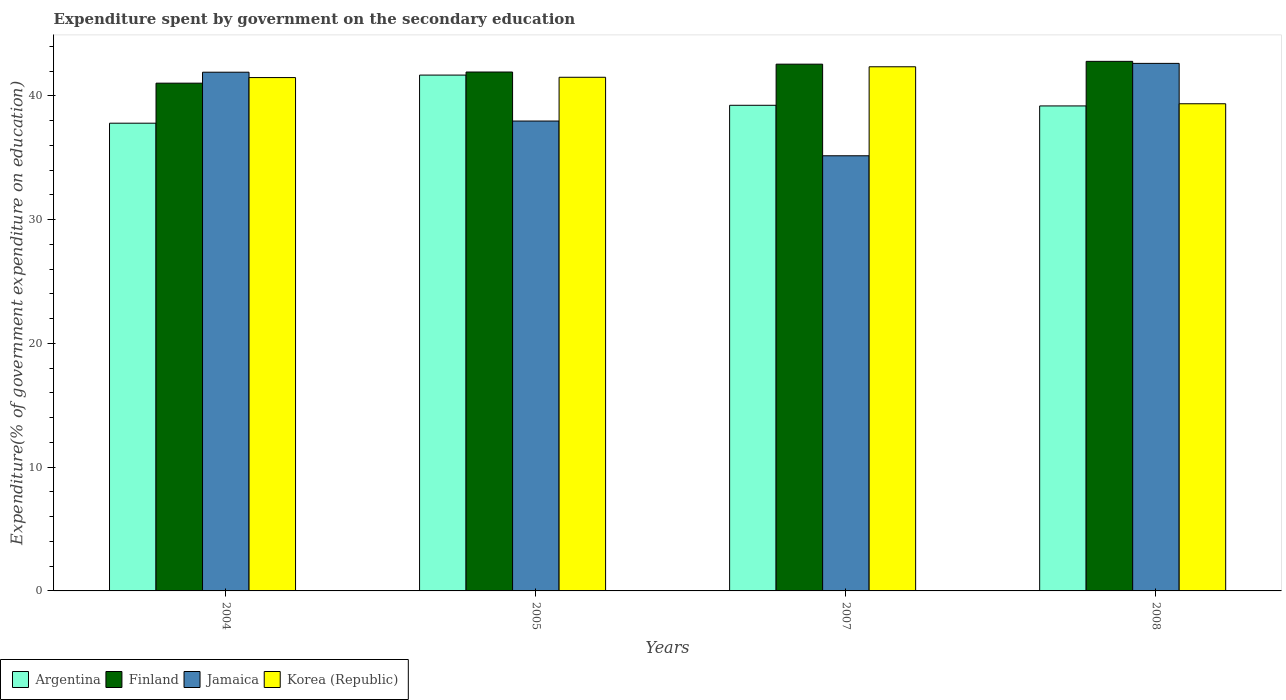How many different coloured bars are there?
Offer a terse response. 4. Are the number of bars per tick equal to the number of legend labels?
Offer a very short reply. Yes. In how many cases, is the number of bars for a given year not equal to the number of legend labels?
Provide a short and direct response. 0. What is the expenditure spent by government on the secondary education in Finland in 2007?
Provide a short and direct response. 42.57. Across all years, what is the maximum expenditure spent by government on the secondary education in Jamaica?
Your answer should be very brief. 42.63. Across all years, what is the minimum expenditure spent by government on the secondary education in Korea (Republic)?
Provide a short and direct response. 39.37. In which year was the expenditure spent by government on the secondary education in Argentina maximum?
Ensure brevity in your answer.  2005. In which year was the expenditure spent by government on the secondary education in Finland minimum?
Your response must be concise. 2004. What is the total expenditure spent by government on the secondary education in Korea (Republic) in the graph?
Provide a short and direct response. 164.72. What is the difference between the expenditure spent by government on the secondary education in Jamaica in 2004 and that in 2008?
Offer a very short reply. -0.71. What is the difference between the expenditure spent by government on the secondary education in Jamaica in 2008 and the expenditure spent by government on the secondary education in Korea (Republic) in 2005?
Offer a terse response. 1.12. What is the average expenditure spent by government on the secondary education in Jamaica per year?
Provide a short and direct response. 39.42. In the year 2005, what is the difference between the expenditure spent by government on the secondary education in Finland and expenditure spent by government on the secondary education in Jamaica?
Make the answer very short. 3.96. What is the ratio of the expenditure spent by government on the secondary education in Korea (Republic) in 2005 to that in 2007?
Your answer should be very brief. 0.98. Is the expenditure spent by government on the secondary education in Korea (Republic) in 2004 less than that in 2007?
Give a very brief answer. Yes. What is the difference between the highest and the second highest expenditure spent by government on the secondary education in Finland?
Offer a terse response. 0.23. What is the difference between the highest and the lowest expenditure spent by government on the secondary education in Jamaica?
Your answer should be very brief. 7.47. Is the sum of the expenditure spent by government on the secondary education in Korea (Republic) in 2004 and 2005 greater than the maximum expenditure spent by government on the secondary education in Argentina across all years?
Offer a terse response. Yes. Is it the case that in every year, the sum of the expenditure spent by government on the secondary education in Jamaica and expenditure spent by government on the secondary education in Finland is greater than the sum of expenditure spent by government on the secondary education in Korea (Republic) and expenditure spent by government on the secondary education in Argentina?
Ensure brevity in your answer.  Yes. What does the 3rd bar from the right in 2007 represents?
Keep it short and to the point. Finland. How many bars are there?
Offer a terse response. 16. Are all the bars in the graph horizontal?
Give a very brief answer. No. How many years are there in the graph?
Your response must be concise. 4. Where does the legend appear in the graph?
Offer a terse response. Bottom left. How many legend labels are there?
Make the answer very short. 4. How are the legend labels stacked?
Ensure brevity in your answer.  Horizontal. What is the title of the graph?
Keep it short and to the point. Expenditure spent by government on the secondary education. Does "Dominican Republic" appear as one of the legend labels in the graph?
Your answer should be compact. No. What is the label or title of the X-axis?
Your response must be concise. Years. What is the label or title of the Y-axis?
Offer a terse response. Expenditure(% of government expenditure on education). What is the Expenditure(% of government expenditure on education) of Argentina in 2004?
Keep it short and to the point. 37.8. What is the Expenditure(% of government expenditure on education) of Finland in 2004?
Your response must be concise. 41.03. What is the Expenditure(% of government expenditure on education) in Jamaica in 2004?
Offer a terse response. 41.92. What is the Expenditure(% of government expenditure on education) of Korea (Republic) in 2004?
Give a very brief answer. 41.49. What is the Expenditure(% of government expenditure on education) of Argentina in 2005?
Your answer should be very brief. 41.69. What is the Expenditure(% of government expenditure on education) in Finland in 2005?
Provide a short and direct response. 41.93. What is the Expenditure(% of government expenditure on education) of Jamaica in 2005?
Give a very brief answer. 37.97. What is the Expenditure(% of government expenditure on education) in Korea (Republic) in 2005?
Provide a short and direct response. 41.51. What is the Expenditure(% of government expenditure on education) in Argentina in 2007?
Your answer should be very brief. 39.25. What is the Expenditure(% of government expenditure on education) in Finland in 2007?
Provide a succinct answer. 42.57. What is the Expenditure(% of government expenditure on education) of Jamaica in 2007?
Provide a succinct answer. 35.17. What is the Expenditure(% of government expenditure on education) in Korea (Republic) in 2007?
Provide a short and direct response. 42.36. What is the Expenditure(% of government expenditure on education) of Argentina in 2008?
Provide a short and direct response. 39.19. What is the Expenditure(% of government expenditure on education) in Finland in 2008?
Give a very brief answer. 42.8. What is the Expenditure(% of government expenditure on education) of Jamaica in 2008?
Your answer should be compact. 42.63. What is the Expenditure(% of government expenditure on education) in Korea (Republic) in 2008?
Give a very brief answer. 39.37. Across all years, what is the maximum Expenditure(% of government expenditure on education) of Argentina?
Make the answer very short. 41.69. Across all years, what is the maximum Expenditure(% of government expenditure on education) in Finland?
Keep it short and to the point. 42.8. Across all years, what is the maximum Expenditure(% of government expenditure on education) of Jamaica?
Make the answer very short. 42.63. Across all years, what is the maximum Expenditure(% of government expenditure on education) in Korea (Republic)?
Your response must be concise. 42.36. Across all years, what is the minimum Expenditure(% of government expenditure on education) in Argentina?
Your answer should be very brief. 37.8. Across all years, what is the minimum Expenditure(% of government expenditure on education) of Finland?
Offer a very short reply. 41.03. Across all years, what is the minimum Expenditure(% of government expenditure on education) in Jamaica?
Your answer should be very brief. 35.17. Across all years, what is the minimum Expenditure(% of government expenditure on education) in Korea (Republic)?
Your response must be concise. 39.37. What is the total Expenditure(% of government expenditure on education) in Argentina in the graph?
Ensure brevity in your answer.  157.93. What is the total Expenditure(% of government expenditure on education) in Finland in the graph?
Ensure brevity in your answer.  168.33. What is the total Expenditure(% of government expenditure on education) in Jamaica in the graph?
Your answer should be very brief. 157.69. What is the total Expenditure(% of government expenditure on education) in Korea (Republic) in the graph?
Provide a short and direct response. 164.72. What is the difference between the Expenditure(% of government expenditure on education) of Argentina in 2004 and that in 2005?
Give a very brief answer. -3.89. What is the difference between the Expenditure(% of government expenditure on education) in Finland in 2004 and that in 2005?
Your response must be concise. -0.9. What is the difference between the Expenditure(% of government expenditure on education) in Jamaica in 2004 and that in 2005?
Your response must be concise. 3.95. What is the difference between the Expenditure(% of government expenditure on education) in Korea (Republic) in 2004 and that in 2005?
Your answer should be very brief. -0.02. What is the difference between the Expenditure(% of government expenditure on education) of Argentina in 2004 and that in 2007?
Offer a very short reply. -1.45. What is the difference between the Expenditure(% of government expenditure on education) in Finland in 2004 and that in 2007?
Give a very brief answer. -1.54. What is the difference between the Expenditure(% of government expenditure on education) of Jamaica in 2004 and that in 2007?
Offer a terse response. 6.75. What is the difference between the Expenditure(% of government expenditure on education) in Korea (Republic) in 2004 and that in 2007?
Provide a short and direct response. -0.87. What is the difference between the Expenditure(% of government expenditure on education) in Argentina in 2004 and that in 2008?
Give a very brief answer. -1.39. What is the difference between the Expenditure(% of government expenditure on education) in Finland in 2004 and that in 2008?
Ensure brevity in your answer.  -1.76. What is the difference between the Expenditure(% of government expenditure on education) of Jamaica in 2004 and that in 2008?
Provide a succinct answer. -0.71. What is the difference between the Expenditure(% of government expenditure on education) of Korea (Republic) in 2004 and that in 2008?
Give a very brief answer. 2.12. What is the difference between the Expenditure(% of government expenditure on education) in Argentina in 2005 and that in 2007?
Provide a short and direct response. 2.44. What is the difference between the Expenditure(% of government expenditure on education) of Finland in 2005 and that in 2007?
Provide a short and direct response. -0.63. What is the difference between the Expenditure(% of government expenditure on education) of Jamaica in 2005 and that in 2007?
Offer a very short reply. 2.81. What is the difference between the Expenditure(% of government expenditure on education) of Korea (Republic) in 2005 and that in 2007?
Provide a succinct answer. -0.85. What is the difference between the Expenditure(% of government expenditure on education) in Argentina in 2005 and that in 2008?
Provide a short and direct response. 2.49. What is the difference between the Expenditure(% of government expenditure on education) of Finland in 2005 and that in 2008?
Your answer should be very brief. -0.86. What is the difference between the Expenditure(% of government expenditure on education) of Jamaica in 2005 and that in 2008?
Offer a very short reply. -4.66. What is the difference between the Expenditure(% of government expenditure on education) of Korea (Republic) in 2005 and that in 2008?
Provide a short and direct response. 2.14. What is the difference between the Expenditure(% of government expenditure on education) of Argentina in 2007 and that in 2008?
Give a very brief answer. 0.05. What is the difference between the Expenditure(% of government expenditure on education) of Finland in 2007 and that in 2008?
Provide a short and direct response. -0.23. What is the difference between the Expenditure(% of government expenditure on education) of Jamaica in 2007 and that in 2008?
Make the answer very short. -7.47. What is the difference between the Expenditure(% of government expenditure on education) in Korea (Republic) in 2007 and that in 2008?
Your answer should be very brief. 2.99. What is the difference between the Expenditure(% of government expenditure on education) in Argentina in 2004 and the Expenditure(% of government expenditure on education) in Finland in 2005?
Your answer should be very brief. -4.14. What is the difference between the Expenditure(% of government expenditure on education) in Argentina in 2004 and the Expenditure(% of government expenditure on education) in Jamaica in 2005?
Offer a terse response. -0.17. What is the difference between the Expenditure(% of government expenditure on education) of Argentina in 2004 and the Expenditure(% of government expenditure on education) of Korea (Republic) in 2005?
Offer a very short reply. -3.71. What is the difference between the Expenditure(% of government expenditure on education) in Finland in 2004 and the Expenditure(% of government expenditure on education) in Jamaica in 2005?
Offer a terse response. 3.06. What is the difference between the Expenditure(% of government expenditure on education) in Finland in 2004 and the Expenditure(% of government expenditure on education) in Korea (Republic) in 2005?
Provide a succinct answer. -0.48. What is the difference between the Expenditure(% of government expenditure on education) in Jamaica in 2004 and the Expenditure(% of government expenditure on education) in Korea (Republic) in 2005?
Make the answer very short. 0.41. What is the difference between the Expenditure(% of government expenditure on education) of Argentina in 2004 and the Expenditure(% of government expenditure on education) of Finland in 2007?
Offer a terse response. -4.77. What is the difference between the Expenditure(% of government expenditure on education) of Argentina in 2004 and the Expenditure(% of government expenditure on education) of Jamaica in 2007?
Your answer should be very brief. 2.63. What is the difference between the Expenditure(% of government expenditure on education) in Argentina in 2004 and the Expenditure(% of government expenditure on education) in Korea (Republic) in 2007?
Give a very brief answer. -4.56. What is the difference between the Expenditure(% of government expenditure on education) in Finland in 2004 and the Expenditure(% of government expenditure on education) in Jamaica in 2007?
Your response must be concise. 5.87. What is the difference between the Expenditure(% of government expenditure on education) in Finland in 2004 and the Expenditure(% of government expenditure on education) in Korea (Republic) in 2007?
Give a very brief answer. -1.32. What is the difference between the Expenditure(% of government expenditure on education) in Jamaica in 2004 and the Expenditure(% of government expenditure on education) in Korea (Republic) in 2007?
Offer a very short reply. -0.44. What is the difference between the Expenditure(% of government expenditure on education) of Argentina in 2004 and the Expenditure(% of government expenditure on education) of Finland in 2008?
Your answer should be very brief. -5. What is the difference between the Expenditure(% of government expenditure on education) of Argentina in 2004 and the Expenditure(% of government expenditure on education) of Jamaica in 2008?
Keep it short and to the point. -4.83. What is the difference between the Expenditure(% of government expenditure on education) of Argentina in 2004 and the Expenditure(% of government expenditure on education) of Korea (Republic) in 2008?
Your answer should be very brief. -1.57. What is the difference between the Expenditure(% of government expenditure on education) of Finland in 2004 and the Expenditure(% of government expenditure on education) of Jamaica in 2008?
Offer a terse response. -1.6. What is the difference between the Expenditure(% of government expenditure on education) of Finland in 2004 and the Expenditure(% of government expenditure on education) of Korea (Republic) in 2008?
Your answer should be very brief. 1.66. What is the difference between the Expenditure(% of government expenditure on education) in Jamaica in 2004 and the Expenditure(% of government expenditure on education) in Korea (Republic) in 2008?
Give a very brief answer. 2.55. What is the difference between the Expenditure(% of government expenditure on education) of Argentina in 2005 and the Expenditure(% of government expenditure on education) of Finland in 2007?
Make the answer very short. -0.88. What is the difference between the Expenditure(% of government expenditure on education) of Argentina in 2005 and the Expenditure(% of government expenditure on education) of Jamaica in 2007?
Offer a terse response. 6.52. What is the difference between the Expenditure(% of government expenditure on education) of Argentina in 2005 and the Expenditure(% of government expenditure on education) of Korea (Republic) in 2007?
Keep it short and to the point. -0.67. What is the difference between the Expenditure(% of government expenditure on education) in Finland in 2005 and the Expenditure(% of government expenditure on education) in Jamaica in 2007?
Make the answer very short. 6.77. What is the difference between the Expenditure(% of government expenditure on education) in Finland in 2005 and the Expenditure(% of government expenditure on education) in Korea (Republic) in 2007?
Provide a succinct answer. -0.42. What is the difference between the Expenditure(% of government expenditure on education) in Jamaica in 2005 and the Expenditure(% of government expenditure on education) in Korea (Republic) in 2007?
Provide a succinct answer. -4.39. What is the difference between the Expenditure(% of government expenditure on education) in Argentina in 2005 and the Expenditure(% of government expenditure on education) in Finland in 2008?
Your answer should be compact. -1.11. What is the difference between the Expenditure(% of government expenditure on education) of Argentina in 2005 and the Expenditure(% of government expenditure on education) of Jamaica in 2008?
Offer a very short reply. -0.95. What is the difference between the Expenditure(% of government expenditure on education) in Argentina in 2005 and the Expenditure(% of government expenditure on education) in Korea (Republic) in 2008?
Give a very brief answer. 2.32. What is the difference between the Expenditure(% of government expenditure on education) of Finland in 2005 and the Expenditure(% of government expenditure on education) of Jamaica in 2008?
Make the answer very short. -0.7. What is the difference between the Expenditure(% of government expenditure on education) of Finland in 2005 and the Expenditure(% of government expenditure on education) of Korea (Republic) in 2008?
Ensure brevity in your answer.  2.56. What is the difference between the Expenditure(% of government expenditure on education) in Jamaica in 2005 and the Expenditure(% of government expenditure on education) in Korea (Republic) in 2008?
Give a very brief answer. -1.4. What is the difference between the Expenditure(% of government expenditure on education) in Argentina in 2007 and the Expenditure(% of government expenditure on education) in Finland in 2008?
Provide a short and direct response. -3.55. What is the difference between the Expenditure(% of government expenditure on education) in Argentina in 2007 and the Expenditure(% of government expenditure on education) in Jamaica in 2008?
Your response must be concise. -3.39. What is the difference between the Expenditure(% of government expenditure on education) of Argentina in 2007 and the Expenditure(% of government expenditure on education) of Korea (Republic) in 2008?
Your answer should be compact. -0.12. What is the difference between the Expenditure(% of government expenditure on education) in Finland in 2007 and the Expenditure(% of government expenditure on education) in Jamaica in 2008?
Provide a short and direct response. -0.06. What is the difference between the Expenditure(% of government expenditure on education) of Finland in 2007 and the Expenditure(% of government expenditure on education) of Korea (Republic) in 2008?
Your response must be concise. 3.2. What is the difference between the Expenditure(% of government expenditure on education) of Jamaica in 2007 and the Expenditure(% of government expenditure on education) of Korea (Republic) in 2008?
Give a very brief answer. -4.2. What is the average Expenditure(% of government expenditure on education) in Argentina per year?
Provide a short and direct response. 39.48. What is the average Expenditure(% of government expenditure on education) of Finland per year?
Your answer should be compact. 42.08. What is the average Expenditure(% of government expenditure on education) of Jamaica per year?
Your response must be concise. 39.42. What is the average Expenditure(% of government expenditure on education) in Korea (Republic) per year?
Keep it short and to the point. 41.18. In the year 2004, what is the difference between the Expenditure(% of government expenditure on education) in Argentina and Expenditure(% of government expenditure on education) in Finland?
Make the answer very short. -3.23. In the year 2004, what is the difference between the Expenditure(% of government expenditure on education) in Argentina and Expenditure(% of government expenditure on education) in Jamaica?
Offer a very short reply. -4.12. In the year 2004, what is the difference between the Expenditure(% of government expenditure on education) in Argentina and Expenditure(% of government expenditure on education) in Korea (Republic)?
Offer a very short reply. -3.69. In the year 2004, what is the difference between the Expenditure(% of government expenditure on education) of Finland and Expenditure(% of government expenditure on education) of Jamaica?
Your answer should be very brief. -0.89. In the year 2004, what is the difference between the Expenditure(% of government expenditure on education) of Finland and Expenditure(% of government expenditure on education) of Korea (Republic)?
Make the answer very short. -0.45. In the year 2004, what is the difference between the Expenditure(% of government expenditure on education) of Jamaica and Expenditure(% of government expenditure on education) of Korea (Republic)?
Give a very brief answer. 0.43. In the year 2005, what is the difference between the Expenditure(% of government expenditure on education) in Argentina and Expenditure(% of government expenditure on education) in Finland?
Provide a short and direct response. -0.25. In the year 2005, what is the difference between the Expenditure(% of government expenditure on education) of Argentina and Expenditure(% of government expenditure on education) of Jamaica?
Provide a short and direct response. 3.71. In the year 2005, what is the difference between the Expenditure(% of government expenditure on education) of Argentina and Expenditure(% of government expenditure on education) of Korea (Republic)?
Offer a very short reply. 0.18. In the year 2005, what is the difference between the Expenditure(% of government expenditure on education) in Finland and Expenditure(% of government expenditure on education) in Jamaica?
Your answer should be compact. 3.96. In the year 2005, what is the difference between the Expenditure(% of government expenditure on education) of Finland and Expenditure(% of government expenditure on education) of Korea (Republic)?
Offer a terse response. 0.42. In the year 2005, what is the difference between the Expenditure(% of government expenditure on education) of Jamaica and Expenditure(% of government expenditure on education) of Korea (Republic)?
Ensure brevity in your answer.  -3.54. In the year 2007, what is the difference between the Expenditure(% of government expenditure on education) in Argentina and Expenditure(% of government expenditure on education) in Finland?
Offer a very short reply. -3.32. In the year 2007, what is the difference between the Expenditure(% of government expenditure on education) in Argentina and Expenditure(% of government expenditure on education) in Jamaica?
Provide a succinct answer. 4.08. In the year 2007, what is the difference between the Expenditure(% of government expenditure on education) of Argentina and Expenditure(% of government expenditure on education) of Korea (Republic)?
Give a very brief answer. -3.11. In the year 2007, what is the difference between the Expenditure(% of government expenditure on education) of Finland and Expenditure(% of government expenditure on education) of Jamaica?
Give a very brief answer. 7.4. In the year 2007, what is the difference between the Expenditure(% of government expenditure on education) in Finland and Expenditure(% of government expenditure on education) in Korea (Republic)?
Provide a succinct answer. 0.21. In the year 2007, what is the difference between the Expenditure(% of government expenditure on education) in Jamaica and Expenditure(% of government expenditure on education) in Korea (Republic)?
Keep it short and to the point. -7.19. In the year 2008, what is the difference between the Expenditure(% of government expenditure on education) of Argentina and Expenditure(% of government expenditure on education) of Finland?
Offer a terse response. -3.6. In the year 2008, what is the difference between the Expenditure(% of government expenditure on education) in Argentina and Expenditure(% of government expenditure on education) in Jamaica?
Your answer should be compact. -3.44. In the year 2008, what is the difference between the Expenditure(% of government expenditure on education) in Argentina and Expenditure(% of government expenditure on education) in Korea (Republic)?
Your response must be concise. -0.18. In the year 2008, what is the difference between the Expenditure(% of government expenditure on education) in Finland and Expenditure(% of government expenditure on education) in Jamaica?
Ensure brevity in your answer.  0.16. In the year 2008, what is the difference between the Expenditure(% of government expenditure on education) in Finland and Expenditure(% of government expenditure on education) in Korea (Republic)?
Your answer should be compact. 3.43. In the year 2008, what is the difference between the Expenditure(% of government expenditure on education) in Jamaica and Expenditure(% of government expenditure on education) in Korea (Republic)?
Ensure brevity in your answer.  3.26. What is the ratio of the Expenditure(% of government expenditure on education) in Argentina in 2004 to that in 2005?
Your response must be concise. 0.91. What is the ratio of the Expenditure(% of government expenditure on education) in Finland in 2004 to that in 2005?
Provide a succinct answer. 0.98. What is the ratio of the Expenditure(% of government expenditure on education) of Jamaica in 2004 to that in 2005?
Provide a short and direct response. 1.1. What is the ratio of the Expenditure(% of government expenditure on education) in Argentina in 2004 to that in 2007?
Your answer should be compact. 0.96. What is the ratio of the Expenditure(% of government expenditure on education) of Finland in 2004 to that in 2007?
Make the answer very short. 0.96. What is the ratio of the Expenditure(% of government expenditure on education) in Jamaica in 2004 to that in 2007?
Offer a very short reply. 1.19. What is the ratio of the Expenditure(% of government expenditure on education) of Korea (Republic) in 2004 to that in 2007?
Offer a very short reply. 0.98. What is the ratio of the Expenditure(% of government expenditure on education) in Argentina in 2004 to that in 2008?
Ensure brevity in your answer.  0.96. What is the ratio of the Expenditure(% of government expenditure on education) in Finland in 2004 to that in 2008?
Provide a short and direct response. 0.96. What is the ratio of the Expenditure(% of government expenditure on education) of Jamaica in 2004 to that in 2008?
Your answer should be very brief. 0.98. What is the ratio of the Expenditure(% of government expenditure on education) of Korea (Republic) in 2004 to that in 2008?
Offer a terse response. 1.05. What is the ratio of the Expenditure(% of government expenditure on education) in Argentina in 2005 to that in 2007?
Provide a short and direct response. 1.06. What is the ratio of the Expenditure(% of government expenditure on education) of Finland in 2005 to that in 2007?
Offer a terse response. 0.99. What is the ratio of the Expenditure(% of government expenditure on education) of Jamaica in 2005 to that in 2007?
Make the answer very short. 1.08. What is the ratio of the Expenditure(% of government expenditure on education) in Korea (Republic) in 2005 to that in 2007?
Keep it short and to the point. 0.98. What is the ratio of the Expenditure(% of government expenditure on education) of Argentina in 2005 to that in 2008?
Offer a terse response. 1.06. What is the ratio of the Expenditure(% of government expenditure on education) in Finland in 2005 to that in 2008?
Offer a very short reply. 0.98. What is the ratio of the Expenditure(% of government expenditure on education) of Jamaica in 2005 to that in 2008?
Your answer should be very brief. 0.89. What is the ratio of the Expenditure(% of government expenditure on education) of Korea (Republic) in 2005 to that in 2008?
Your answer should be very brief. 1.05. What is the ratio of the Expenditure(% of government expenditure on education) in Argentina in 2007 to that in 2008?
Ensure brevity in your answer.  1. What is the ratio of the Expenditure(% of government expenditure on education) in Jamaica in 2007 to that in 2008?
Give a very brief answer. 0.82. What is the ratio of the Expenditure(% of government expenditure on education) of Korea (Republic) in 2007 to that in 2008?
Your answer should be very brief. 1.08. What is the difference between the highest and the second highest Expenditure(% of government expenditure on education) of Argentina?
Your answer should be compact. 2.44. What is the difference between the highest and the second highest Expenditure(% of government expenditure on education) of Finland?
Your response must be concise. 0.23. What is the difference between the highest and the second highest Expenditure(% of government expenditure on education) in Jamaica?
Your response must be concise. 0.71. What is the difference between the highest and the second highest Expenditure(% of government expenditure on education) of Korea (Republic)?
Ensure brevity in your answer.  0.85. What is the difference between the highest and the lowest Expenditure(% of government expenditure on education) of Argentina?
Your response must be concise. 3.89. What is the difference between the highest and the lowest Expenditure(% of government expenditure on education) of Finland?
Make the answer very short. 1.76. What is the difference between the highest and the lowest Expenditure(% of government expenditure on education) of Jamaica?
Make the answer very short. 7.47. What is the difference between the highest and the lowest Expenditure(% of government expenditure on education) of Korea (Republic)?
Ensure brevity in your answer.  2.99. 